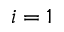<formula> <loc_0><loc_0><loc_500><loc_500>i = 1</formula> 